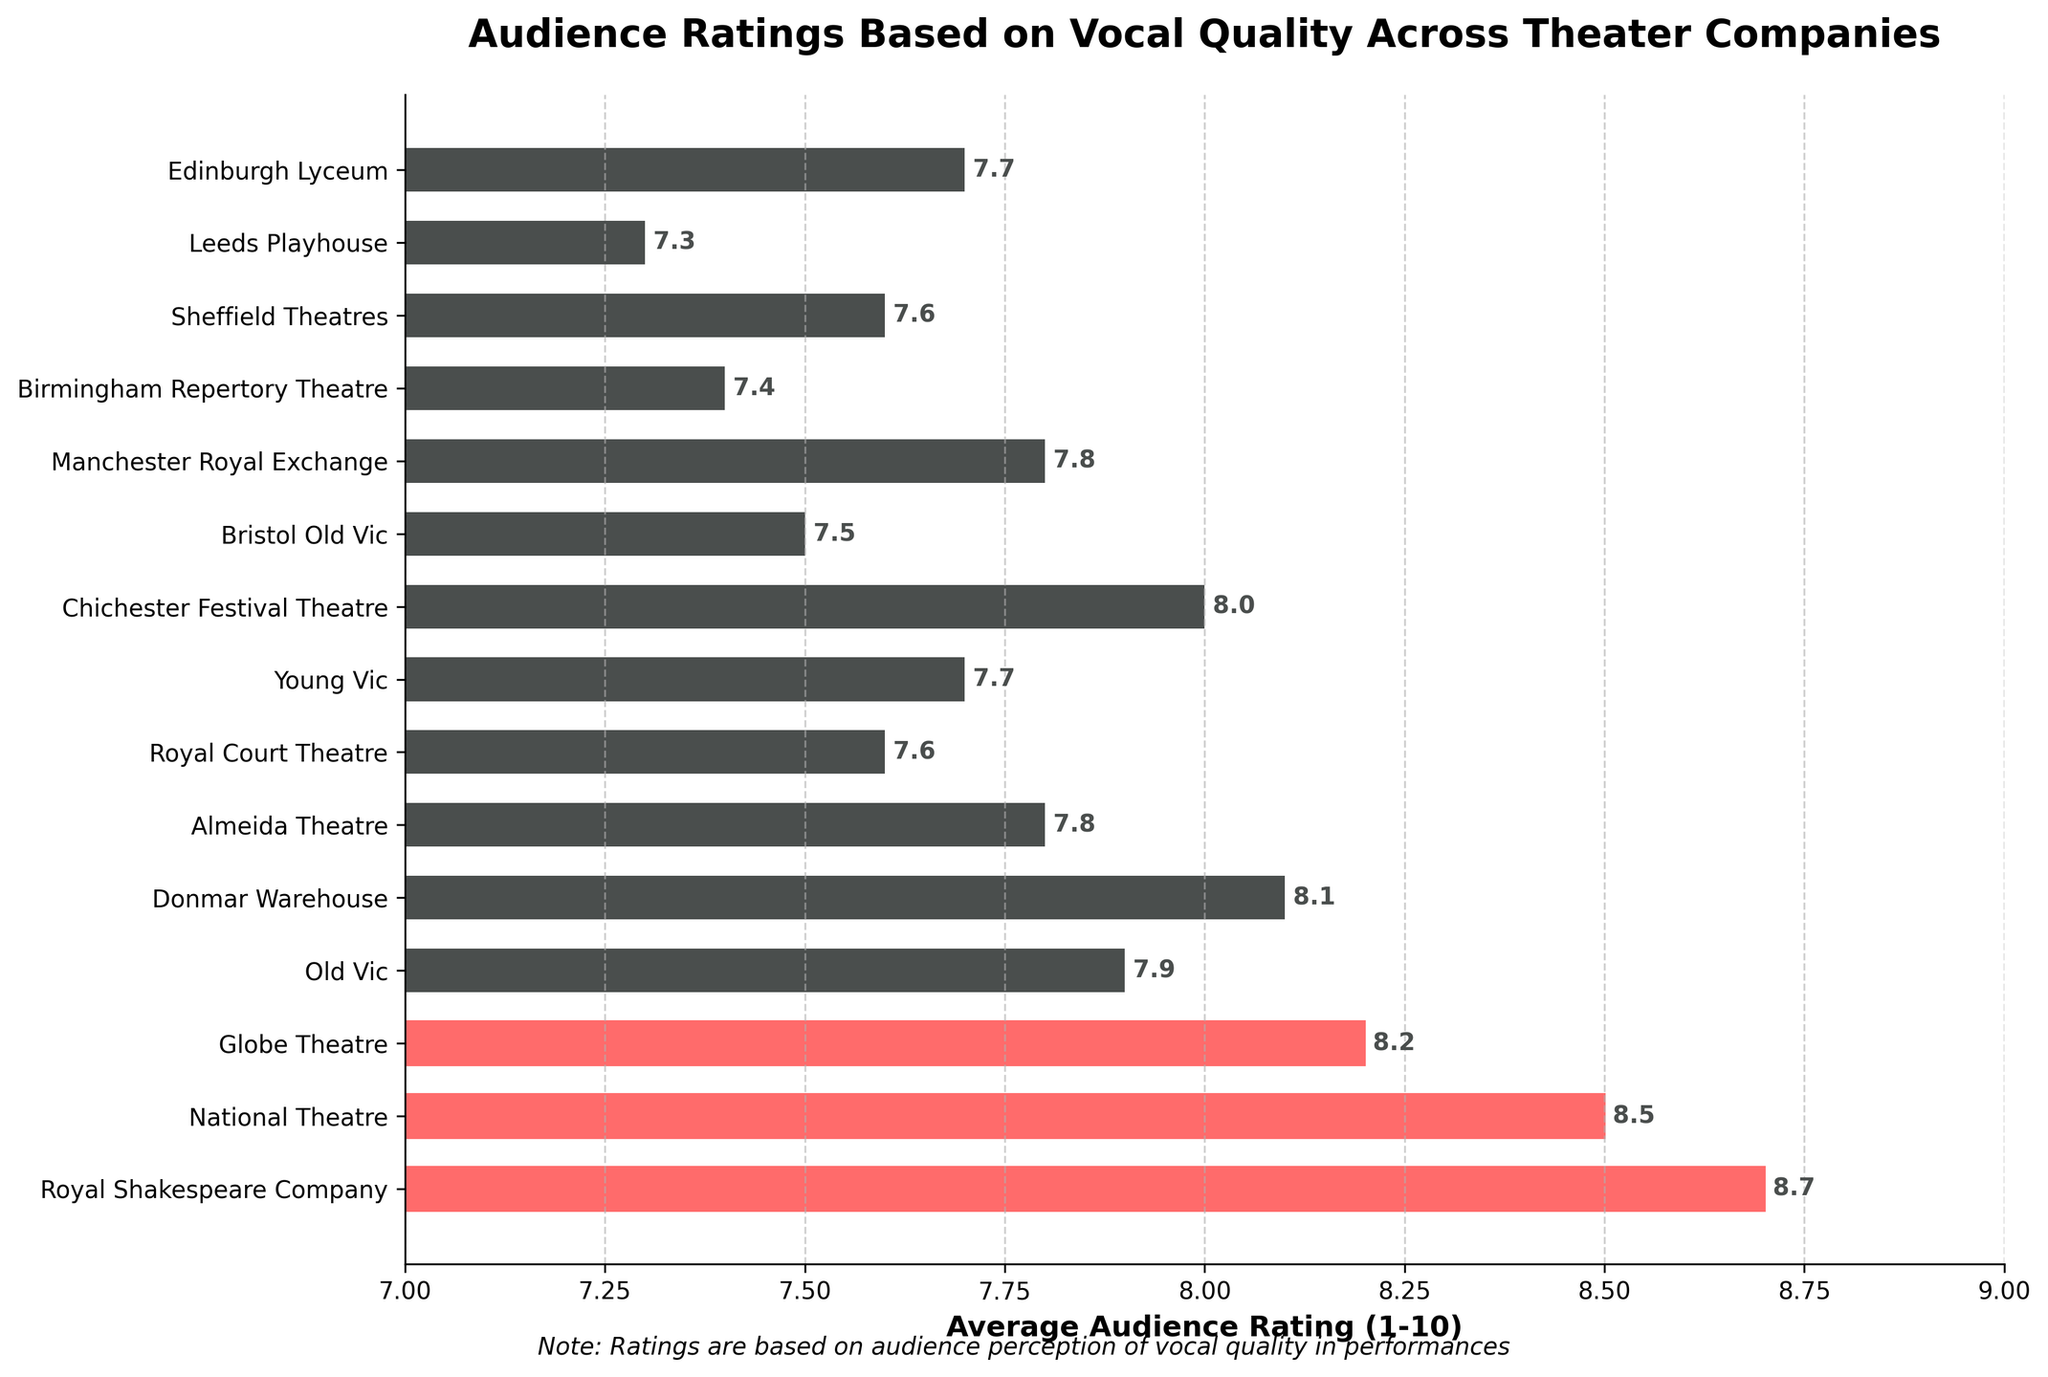Which theater company received the highest average audience rating? The bar at the top of the chart is the tallest and indicates the highest average rating. The Royal Shakespeare Company received the highest rating, which is 8.7.
Answer: Royal Shakespeare Company Which theater companies are highlighted in red? The top three bars are highlighted in red, indicating the Royal Shakespeare Company, National Theatre, and Globe Theatre.
Answer: Royal Shakespeare Company, National Theatre, Globe Theatre How much higher is the average rating of the Royal Shakespeare Company compared to the Birmingham Repertory Theatre? Subtract the rating of the Birmingham Repertory Theatre (7.4) from the rating of the Royal Shakespeare Company (8.7). 8.7 - 7.4 = 1.3.
Answer: 1.3 What is the average rating of theater companies that start with 'Royal'? Sum the ratings of Royal Shakespeare Company (8.7), Royal Court Theatre (7.6), and Manchester Royal Exchange (7.8), then divide by 3. (8.7 + 7.6 + 7.8) / 3 = 8.03.
Answer: 8.03 Which theater company has the lowest average audience rating? The Bristol Old Vic bar is the shortest, which indicates the lowest average rating at 7.3.
Answer: Bristol Old Vic How does the rating of Almeida Theatre compare to Young Vic? Check the ratings of both theaters: Almeida Theatre is 7.8 and Young Vic is 7.7. Almeida Theatre has a slightly higher rating.
Answer: Almeida Theatre is higher What is the combined rating of the top three theater companies? Add the ratings of Royal Shakespeare Company (8.7), National Theatre (8.5), and Globe Theatre (8.2). 8.7 + 8.5 + 8.2 = 25.4.
Answer: 25.4 Which theater companies have the same rating as 7.6? Look for bars with the rating 7.6, which are Royal Court Theatre and Sheffield Theatres.
Answer: Royal Court Theatre, Sheffield Theatres What is the difference in average rating between Chichester Festival Theatre and Old Vic? Subtract the rating of Old Vic (7.9) from the rating of Chichester Festival Theatre (8.0). 8.0 - 7.9 = 0.1.
Answer: 0.1 How many theater companies have a rating below 8.0? Count the bars with ratings below 8.0: Old Vic, Almeida Theatre, Royal Court Theatre, Young Vic, Bristol Old Vic, Birmingham Repertory Theatre, Sheffield Theatres, Leeds Playhouse, Edinburgh Lyceum (9 in total).
Answer: 9 